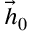<formula> <loc_0><loc_0><loc_500><loc_500>\vec { h } _ { 0 }</formula> 